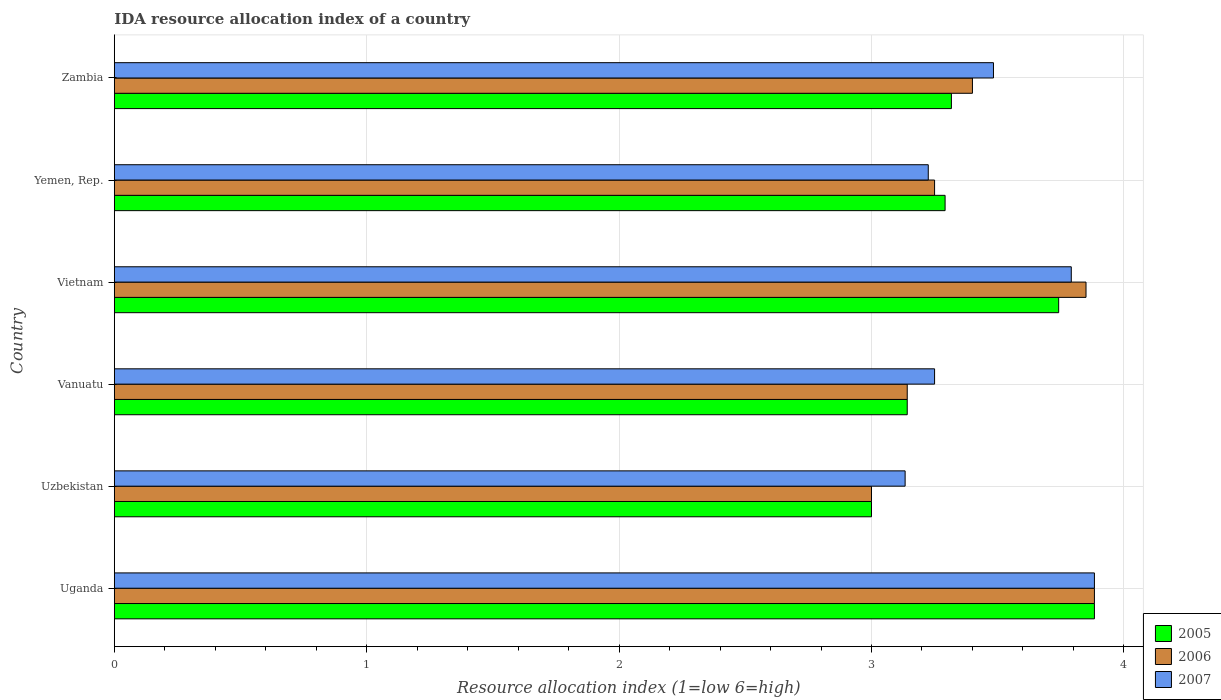How many groups of bars are there?
Your answer should be very brief. 6. How many bars are there on the 2nd tick from the bottom?
Provide a short and direct response. 3. What is the label of the 3rd group of bars from the top?
Your response must be concise. Vietnam. In how many cases, is the number of bars for a given country not equal to the number of legend labels?
Offer a very short reply. 0. What is the IDA resource allocation index in 2006 in Vanuatu?
Your response must be concise. 3.14. Across all countries, what is the maximum IDA resource allocation index in 2007?
Offer a very short reply. 3.88. Across all countries, what is the minimum IDA resource allocation index in 2006?
Provide a succinct answer. 3. In which country was the IDA resource allocation index in 2005 maximum?
Provide a short and direct response. Uganda. In which country was the IDA resource allocation index in 2007 minimum?
Ensure brevity in your answer.  Uzbekistan. What is the total IDA resource allocation index in 2006 in the graph?
Your response must be concise. 20.52. What is the difference between the IDA resource allocation index in 2007 in Uganda and that in Zambia?
Your answer should be compact. 0.4. What is the difference between the IDA resource allocation index in 2007 in Uganda and the IDA resource allocation index in 2006 in Vanuatu?
Provide a succinct answer. 0.74. What is the average IDA resource allocation index in 2005 per country?
Your answer should be very brief. 3.4. What is the difference between the IDA resource allocation index in 2007 and IDA resource allocation index in 2006 in Uzbekistan?
Provide a short and direct response. 0.13. In how many countries, is the IDA resource allocation index in 2007 greater than 3.4 ?
Ensure brevity in your answer.  3. What is the ratio of the IDA resource allocation index in 2007 in Vanuatu to that in Zambia?
Provide a short and direct response. 0.93. Is the difference between the IDA resource allocation index in 2007 in Yemen, Rep. and Zambia greater than the difference between the IDA resource allocation index in 2006 in Yemen, Rep. and Zambia?
Your response must be concise. No. What is the difference between the highest and the second highest IDA resource allocation index in 2006?
Offer a terse response. 0.03. What is the difference between the highest and the lowest IDA resource allocation index in 2007?
Your response must be concise. 0.75. In how many countries, is the IDA resource allocation index in 2006 greater than the average IDA resource allocation index in 2006 taken over all countries?
Ensure brevity in your answer.  2. Is the sum of the IDA resource allocation index in 2007 in Vanuatu and Zambia greater than the maximum IDA resource allocation index in 2006 across all countries?
Your answer should be very brief. Yes. What does the 1st bar from the top in Vietnam represents?
Your answer should be compact. 2007. What does the 1st bar from the bottom in Uzbekistan represents?
Your answer should be very brief. 2005. Are all the bars in the graph horizontal?
Offer a very short reply. Yes. What is the difference between two consecutive major ticks on the X-axis?
Make the answer very short. 1. Are the values on the major ticks of X-axis written in scientific E-notation?
Offer a very short reply. No. Does the graph contain any zero values?
Provide a short and direct response. No. Does the graph contain grids?
Your answer should be compact. Yes. Where does the legend appear in the graph?
Make the answer very short. Bottom right. How are the legend labels stacked?
Your answer should be compact. Vertical. What is the title of the graph?
Offer a terse response. IDA resource allocation index of a country. What is the label or title of the X-axis?
Offer a terse response. Resource allocation index (1=low 6=high). What is the Resource allocation index (1=low 6=high) of 2005 in Uganda?
Make the answer very short. 3.88. What is the Resource allocation index (1=low 6=high) in 2006 in Uganda?
Provide a short and direct response. 3.88. What is the Resource allocation index (1=low 6=high) in 2007 in Uganda?
Your answer should be compact. 3.88. What is the Resource allocation index (1=low 6=high) in 2006 in Uzbekistan?
Keep it short and to the point. 3. What is the Resource allocation index (1=low 6=high) in 2007 in Uzbekistan?
Provide a short and direct response. 3.13. What is the Resource allocation index (1=low 6=high) of 2005 in Vanuatu?
Your answer should be very brief. 3.14. What is the Resource allocation index (1=low 6=high) in 2006 in Vanuatu?
Your response must be concise. 3.14. What is the Resource allocation index (1=low 6=high) of 2005 in Vietnam?
Ensure brevity in your answer.  3.74. What is the Resource allocation index (1=low 6=high) in 2006 in Vietnam?
Your answer should be very brief. 3.85. What is the Resource allocation index (1=low 6=high) of 2007 in Vietnam?
Your response must be concise. 3.79. What is the Resource allocation index (1=low 6=high) in 2005 in Yemen, Rep.?
Provide a short and direct response. 3.29. What is the Resource allocation index (1=low 6=high) in 2007 in Yemen, Rep.?
Give a very brief answer. 3.23. What is the Resource allocation index (1=low 6=high) of 2005 in Zambia?
Offer a terse response. 3.32. What is the Resource allocation index (1=low 6=high) in 2006 in Zambia?
Provide a short and direct response. 3.4. What is the Resource allocation index (1=low 6=high) in 2007 in Zambia?
Your answer should be very brief. 3.48. Across all countries, what is the maximum Resource allocation index (1=low 6=high) in 2005?
Make the answer very short. 3.88. Across all countries, what is the maximum Resource allocation index (1=low 6=high) in 2006?
Provide a succinct answer. 3.88. Across all countries, what is the maximum Resource allocation index (1=low 6=high) of 2007?
Provide a succinct answer. 3.88. Across all countries, what is the minimum Resource allocation index (1=low 6=high) in 2005?
Your answer should be compact. 3. Across all countries, what is the minimum Resource allocation index (1=low 6=high) of 2007?
Provide a short and direct response. 3.13. What is the total Resource allocation index (1=low 6=high) of 2005 in the graph?
Provide a succinct answer. 20.38. What is the total Resource allocation index (1=low 6=high) of 2006 in the graph?
Offer a very short reply. 20.52. What is the total Resource allocation index (1=low 6=high) of 2007 in the graph?
Keep it short and to the point. 20.77. What is the difference between the Resource allocation index (1=low 6=high) in 2005 in Uganda and that in Uzbekistan?
Offer a terse response. 0.88. What is the difference between the Resource allocation index (1=low 6=high) of 2006 in Uganda and that in Uzbekistan?
Keep it short and to the point. 0.88. What is the difference between the Resource allocation index (1=low 6=high) in 2005 in Uganda and that in Vanuatu?
Ensure brevity in your answer.  0.74. What is the difference between the Resource allocation index (1=low 6=high) of 2006 in Uganda and that in Vanuatu?
Your answer should be compact. 0.74. What is the difference between the Resource allocation index (1=low 6=high) of 2007 in Uganda and that in Vanuatu?
Your response must be concise. 0.63. What is the difference between the Resource allocation index (1=low 6=high) in 2005 in Uganda and that in Vietnam?
Ensure brevity in your answer.  0.14. What is the difference between the Resource allocation index (1=low 6=high) in 2006 in Uganda and that in Vietnam?
Your answer should be very brief. 0.03. What is the difference between the Resource allocation index (1=low 6=high) of 2007 in Uganda and that in Vietnam?
Ensure brevity in your answer.  0.09. What is the difference between the Resource allocation index (1=low 6=high) of 2005 in Uganda and that in Yemen, Rep.?
Offer a terse response. 0.59. What is the difference between the Resource allocation index (1=low 6=high) of 2006 in Uganda and that in Yemen, Rep.?
Provide a short and direct response. 0.63. What is the difference between the Resource allocation index (1=low 6=high) of 2007 in Uganda and that in Yemen, Rep.?
Your response must be concise. 0.66. What is the difference between the Resource allocation index (1=low 6=high) of 2005 in Uganda and that in Zambia?
Offer a very short reply. 0.57. What is the difference between the Resource allocation index (1=low 6=high) of 2006 in Uganda and that in Zambia?
Your answer should be very brief. 0.48. What is the difference between the Resource allocation index (1=low 6=high) in 2005 in Uzbekistan and that in Vanuatu?
Your response must be concise. -0.14. What is the difference between the Resource allocation index (1=low 6=high) of 2006 in Uzbekistan and that in Vanuatu?
Make the answer very short. -0.14. What is the difference between the Resource allocation index (1=low 6=high) of 2007 in Uzbekistan and that in Vanuatu?
Give a very brief answer. -0.12. What is the difference between the Resource allocation index (1=low 6=high) in 2005 in Uzbekistan and that in Vietnam?
Provide a succinct answer. -0.74. What is the difference between the Resource allocation index (1=low 6=high) in 2006 in Uzbekistan and that in Vietnam?
Your answer should be very brief. -0.85. What is the difference between the Resource allocation index (1=low 6=high) of 2007 in Uzbekistan and that in Vietnam?
Provide a short and direct response. -0.66. What is the difference between the Resource allocation index (1=low 6=high) in 2005 in Uzbekistan and that in Yemen, Rep.?
Offer a terse response. -0.29. What is the difference between the Resource allocation index (1=low 6=high) in 2006 in Uzbekistan and that in Yemen, Rep.?
Ensure brevity in your answer.  -0.25. What is the difference between the Resource allocation index (1=low 6=high) in 2007 in Uzbekistan and that in Yemen, Rep.?
Your answer should be very brief. -0.09. What is the difference between the Resource allocation index (1=low 6=high) of 2005 in Uzbekistan and that in Zambia?
Keep it short and to the point. -0.32. What is the difference between the Resource allocation index (1=low 6=high) in 2006 in Uzbekistan and that in Zambia?
Provide a succinct answer. -0.4. What is the difference between the Resource allocation index (1=low 6=high) in 2007 in Uzbekistan and that in Zambia?
Keep it short and to the point. -0.35. What is the difference between the Resource allocation index (1=low 6=high) in 2006 in Vanuatu and that in Vietnam?
Provide a succinct answer. -0.71. What is the difference between the Resource allocation index (1=low 6=high) in 2007 in Vanuatu and that in Vietnam?
Give a very brief answer. -0.54. What is the difference between the Resource allocation index (1=low 6=high) in 2005 in Vanuatu and that in Yemen, Rep.?
Provide a succinct answer. -0.15. What is the difference between the Resource allocation index (1=low 6=high) of 2006 in Vanuatu and that in Yemen, Rep.?
Your response must be concise. -0.11. What is the difference between the Resource allocation index (1=low 6=high) of 2007 in Vanuatu and that in Yemen, Rep.?
Make the answer very short. 0.03. What is the difference between the Resource allocation index (1=low 6=high) in 2005 in Vanuatu and that in Zambia?
Your answer should be compact. -0.17. What is the difference between the Resource allocation index (1=low 6=high) in 2006 in Vanuatu and that in Zambia?
Your answer should be compact. -0.26. What is the difference between the Resource allocation index (1=low 6=high) of 2007 in Vanuatu and that in Zambia?
Keep it short and to the point. -0.23. What is the difference between the Resource allocation index (1=low 6=high) of 2005 in Vietnam and that in Yemen, Rep.?
Offer a very short reply. 0.45. What is the difference between the Resource allocation index (1=low 6=high) of 2006 in Vietnam and that in Yemen, Rep.?
Offer a very short reply. 0.6. What is the difference between the Resource allocation index (1=low 6=high) of 2007 in Vietnam and that in Yemen, Rep.?
Provide a succinct answer. 0.57. What is the difference between the Resource allocation index (1=low 6=high) in 2005 in Vietnam and that in Zambia?
Offer a very short reply. 0.42. What is the difference between the Resource allocation index (1=low 6=high) in 2006 in Vietnam and that in Zambia?
Provide a succinct answer. 0.45. What is the difference between the Resource allocation index (1=low 6=high) in 2007 in Vietnam and that in Zambia?
Your answer should be compact. 0.31. What is the difference between the Resource allocation index (1=low 6=high) in 2005 in Yemen, Rep. and that in Zambia?
Provide a short and direct response. -0.03. What is the difference between the Resource allocation index (1=low 6=high) in 2007 in Yemen, Rep. and that in Zambia?
Ensure brevity in your answer.  -0.26. What is the difference between the Resource allocation index (1=low 6=high) of 2005 in Uganda and the Resource allocation index (1=low 6=high) of 2006 in Uzbekistan?
Provide a succinct answer. 0.88. What is the difference between the Resource allocation index (1=low 6=high) of 2005 in Uganda and the Resource allocation index (1=low 6=high) of 2006 in Vanuatu?
Give a very brief answer. 0.74. What is the difference between the Resource allocation index (1=low 6=high) in 2005 in Uganda and the Resource allocation index (1=low 6=high) in 2007 in Vanuatu?
Your answer should be compact. 0.63. What is the difference between the Resource allocation index (1=low 6=high) of 2006 in Uganda and the Resource allocation index (1=low 6=high) of 2007 in Vanuatu?
Make the answer very short. 0.63. What is the difference between the Resource allocation index (1=low 6=high) in 2005 in Uganda and the Resource allocation index (1=low 6=high) in 2006 in Vietnam?
Your answer should be very brief. 0.03. What is the difference between the Resource allocation index (1=low 6=high) in 2005 in Uganda and the Resource allocation index (1=low 6=high) in 2007 in Vietnam?
Provide a succinct answer. 0.09. What is the difference between the Resource allocation index (1=low 6=high) of 2006 in Uganda and the Resource allocation index (1=low 6=high) of 2007 in Vietnam?
Make the answer very short. 0.09. What is the difference between the Resource allocation index (1=low 6=high) of 2005 in Uganda and the Resource allocation index (1=low 6=high) of 2006 in Yemen, Rep.?
Your response must be concise. 0.63. What is the difference between the Resource allocation index (1=low 6=high) of 2005 in Uganda and the Resource allocation index (1=low 6=high) of 2007 in Yemen, Rep.?
Ensure brevity in your answer.  0.66. What is the difference between the Resource allocation index (1=low 6=high) in 2006 in Uganda and the Resource allocation index (1=low 6=high) in 2007 in Yemen, Rep.?
Provide a short and direct response. 0.66. What is the difference between the Resource allocation index (1=low 6=high) of 2005 in Uganda and the Resource allocation index (1=low 6=high) of 2006 in Zambia?
Your answer should be very brief. 0.48. What is the difference between the Resource allocation index (1=low 6=high) of 2005 in Uzbekistan and the Resource allocation index (1=low 6=high) of 2006 in Vanuatu?
Give a very brief answer. -0.14. What is the difference between the Resource allocation index (1=low 6=high) in 2005 in Uzbekistan and the Resource allocation index (1=low 6=high) in 2006 in Vietnam?
Your answer should be compact. -0.85. What is the difference between the Resource allocation index (1=low 6=high) in 2005 in Uzbekistan and the Resource allocation index (1=low 6=high) in 2007 in Vietnam?
Give a very brief answer. -0.79. What is the difference between the Resource allocation index (1=low 6=high) of 2006 in Uzbekistan and the Resource allocation index (1=low 6=high) of 2007 in Vietnam?
Your answer should be very brief. -0.79. What is the difference between the Resource allocation index (1=low 6=high) of 2005 in Uzbekistan and the Resource allocation index (1=low 6=high) of 2007 in Yemen, Rep.?
Your answer should be very brief. -0.23. What is the difference between the Resource allocation index (1=low 6=high) of 2006 in Uzbekistan and the Resource allocation index (1=low 6=high) of 2007 in Yemen, Rep.?
Provide a succinct answer. -0.23. What is the difference between the Resource allocation index (1=low 6=high) of 2005 in Uzbekistan and the Resource allocation index (1=low 6=high) of 2006 in Zambia?
Provide a short and direct response. -0.4. What is the difference between the Resource allocation index (1=low 6=high) in 2005 in Uzbekistan and the Resource allocation index (1=low 6=high) in 2007 in Zambia?
Keep it short and to the point. -0.48. What is the difference between the Resource allocation index (1=low 6=high) of 2006 in Uzbekistan and the Resource allocation index (1=low 6=high) of 2007 in Zambia?
Give a very brief answer. -0.48. What is the difference between the Resource allocation index (1=low 6=high) in 2005 in Vanuatu and the Resource allocation index (1=low 6=high) in 2006 in Vietnam?
Provide a short and direct response. -0.71. What is the difference between the Resource allocation index (1=low 6=high) in 2005 in Vanuatu and the Resource allocation index (1=low 6=high) in 2007 in Vietnam?
Your response must be concise. -0.65. What is the difference between the Resource allocation index (1=low 6=high) of 2006 in Vanuatu and the Resource allocation index (1=low 6=high) of 2007 in Vietnam?
Give a very brief answer. -0.65. What is the difference between the Resource allocation index (1=low 6=high) in 2005 in Vanuatu and the Resource allocation index (1=low 6=high) in 2006 in Yemen, Rep.?
Your response must be concise. -0.11. What is the difference between the Resource allocation index (1=low 6=high) of 2005 in Vanuatu and the Resource allocation index (1=low 6=high) of 2007 in Yemen, Rep.?
Your response must be concise. -0.08. What is the difference between the Resource allocation index (1=low 6=high) in 2006 in Vanuatu and the Resource allocation index (1=low 6=high) in 2007 in Yemen, Rep.?
Offer a very short reply. -0.08. What is the difference between the Resource allocation index (1=low 6=high) of 2005 in Vanuatu and the Resource allocation index (1=low 6=high) of 2006 in Zambia?
Your answer should be compact. -0.26. What is the difference between the Resource allocation index (1=low 6=high) of 2005 in Vanuatu and the Resource allocation index (1=low 6=high) of 2007 in Zambia?
Provide a short and direct response. -0.34. What is the difference between the Resource allocation index (1=low 6=high) in 2006 in Vanuatu and the Resource allocation index (1=low 6=high) in 2007 in Zambia?
Ensure brevity in your answer.  -0.34. What is the difference between the Resource allocation index (1=low 6=high) in 2005 in Vietnam and the Resource allocation index (1=low 6=high) in 2006 in Yemen, Rep.?
Your response must be concise. 0.49. What is the difference between the Resource allocation index (1=low 6=high) in 2005 in Vietnam and the Resource allocation index (1=low 6=high) in 2007 in Yemen, Rep.?
Ensure brevity in your answer.  0.52. What is the difference between the Resource allocation index (1=low 6=high) of 2006 in Vietnam and the Resource allocation index (1=low 6=high) of 2007 in Yemen, Rep.?
Your answer should be compact. 0.62. What is the difference between the Resource allocation index (1=low 6=high) of 2005 in Vietnam and the Resource allocation index (1=low 6=high) of 2006 in Zambia?
Give a very brief answer. 0.34. What is the difference between the Resource allocation index (1=low 6=high) in 2005 in Vietnam and the Resource allocation index (1=low 6=high) in 2007 in Zambia?
Give a very brief answer. 0.26. What is the difference between the Resource allocation index (1=low 6=high) of 2006 in Vietnam and the Resource allocation index (1=low 6=high) of 2007 in Zambia?
Provide a short and direct response. 0.37. What is the difference between the Resource allocation index (1=low 6=high) of 2005 in Yemen, Rep. and the Resource allocation index (1=low 6=high) of 2006 in Zambia?
Offer a terse response. -0.11. What is the difference between the Resource allocation index (1=low 6=high) of 2005 in Yemen, Rep. and the Resource allocation index (1=low 6=high) of 2007 in Zambia?
Provide a short and direct response. -0.19. What is the difference between the Resource allocation index (1=low 6=high) in 2006 in Yemen, Rep. and the Resource allocation index (1=low 6=high) in 2007 in Zambia?
Give a very brief answer. -0.23. What is the average Resource allocation index (1=low 6=high) of 2005 per country?
Provide a short and direct response. 3.4. What is the average Resource allocation index (1=low 6=high) of 2006 per country?
Provide a succinct answer. 3.42. What is the average Resource allocation index (1=low 6=high) of 2007 per country?
Keep it short and to the point. 3.46. What is the difference between the Resource allocation index (1=low 6=high) of 2006 and Resource allocation index (1=low 6=high) of 2007 in Uganda?
Keep it short and to the point. 0. What is the difference between the Resource allocation index (1=low 6=high) of 2005 and Resource allocation index (1=low 6=high) of 2007 in Uzbekistan?
Your answer should be compact. -0.13. What is the difference between the Resource allocation index (1=low 6=high) in 2006 and Resource allocation index (1=low 6=high) in 2007 in Uzbekistan?
Give a very brief answer. -0.13. What is the difference between the Resource allocation index (1=low 6=high) in 2005 and Resource allocation index (1=low 6=high) in 2007 in Vanuatu?
Make the answer very short. -0.11. What is the difference between the Resource allocation index (1=low 6=high) in 2006 and Resource allocation index (1=low 6=high) in 2007 in Vanuatu?
Give a very brief answer. -0.11. What is the difference between the Resource allocation index (1=low 6=high) in 2005 and Resource allocation index (1=low 6=high) in 2006 in Vietnam?
Keep it short and to the point. -0.11. What is the difference between the Resource allocation index (1=low 6=high) of 2005 and Resource allocation index (1=low 6=high) of 2007 in Vietnam?
Provide a short and direct response. -0.05. What is the difference between the Resource allocation index (1=low 6=high) in 2006 and Resource allocation index (1=low 6=high) in 2007 in Vietnam?
Offer a terse response. 0.06. What is the difference between the Resource allocation index (1=low 6=high) of 2005 and Resource allocation index (1=low 6=high) of 2006 in Yemen, Rep.?
Offer a very short reply. 0.04. What is the difference between the Resource allocation index (1=low 6=high) of 2005 and Resource allocation index (1=low 6=high) of 2007 in Yemen, Rep.?
Your answer should be compact. 0.07. What is the difference between the Resource allocation index (1=low 6=high) in 2006 and Resource allocation index (1=low 6=high) in 2007 in Yemen, Rep.?
Provide a succinct answer. 0.03. What is the difference between the Resource allocation index (1=low 6=high) in 2005 and Resource allocation index (1=low 6=high) in 2006 in Zambia?
Your response must be concise. -0.08. What is the difference between the Resource allocation index (1=low 6=high) of 2006 and Resource allocation index (1=low 6=high) of 2007 in Zambia?
Offer a terse response. -0.08. What is the ratio of the Resource allocation index (1=low 6=high) of 2005 in Uganda to that in Uzbekistan?
Provide a short and direct response. 1.29. What is the ratio of the Resource allocation index (1=low 6=high) in 2006 in Uganda to that in Uzbekistan?
Provide a short and direct response. 1.29. What is the ratio of the Resource allocation index (1=low 6=high) in 2007 in Uganda to that in Uzbekistan?
Offer a very short reply. 1.24. What is the ratio of the Resource allocation index (1=low 6=high) in 2005 in Uganda to that in Vanuatu?
Provide a succinct answer. 1.24. What is the ratio of the Resource allocation index (1=low 6=high) in 2006 in Uganda to that in Vanuatu?
Give a very brief answer. 1.24. What is the ratio of the Resource allocation index (1=low 6=high) of 2007 in Uganda to that in Vanuatu?
Make the answer very short. 1.19. What is the ratio of the Resource allocation index (1=low 6=high) of 2005 in Uganda to that in Vietnam?
Ensure brevity in your answer.  1.04. What is the ratio of the Resource allocation index (1=low 6=high) of 2006 in Uganda to that in Vietnam?
Keep it short and to the point. 1.01. What is the ratio of the Resource allocation index (1=low 6=high) in 2007 in Uganda to that in Vietnam?
Make the answer very short. 1.02. What is the ratio of the Resource allocation index (1=low 6=high) in 2005 in Uganda to that in Yemen, Rep.?
Keep it short and to the point. 1.18. What is the ratio of the Resource allocation index (1=low 6=high) in 2006 in Uganda to that in Yemen, Rep.?
Give a very brief answer. 1.19. What is the ratio of the Resource allocation index (1=low 6=high) in 2007 in Uganda to that in Yemen, Rep.?
Offer a terse response. 1.2. What is the ratio of the Resource allocation index (1=low 6=high) in 2005 in Uganda to that in Zambia?
Make the answer very short. 1.17. What is the ratio of the Resource allocation index (1=low 6=high) in 2006 in Uganda to that in Zambia?
Give a very brief answer. 1.14. What is the ratio of the Resource allocation index (1=low 6=high) in 2007 in Uganda to that in Zambia?
Your answer should be compact. 1.11. What is the ratio of the Resource allocation index (1=low 6=high) in 2005 in Uzbekistan to that in Vanuatu?
Ensure brevity in your answer.  0.95. What is the ratio of the Resource allocation index (1=low 6=high) of 2006 in Uzbekistan to that in Vanuatu?
Offer a very short reply. 0.95. What is the ratio of the Resource allocation index (1=low 6=high) of 2007 in Uzbekistan to that in Vanuatu?
Give a very brief answer. 0.96. What is the ratio of the Resource allocation index (1=low 6=high) of 2005 in Uzbekistan to that in Vietnam?
Keep it short and to the point. 0.8. What is the ratio of the Resource allocation index (1=low 6=high) of 2006 in Uzbekistan to that in Vietnam?
Your response must be concise. 0.78. What is the ratio of the Resource allocation index (1=low 6=high) of 2007 in Uzbekistan to that in Vietnam?
Your response must be concise. 0.83. What is the ratio of the Resource allocation index (1=low 6=high) in 2005 in Uzbekistan to that in Yemen, Rep.?
Offer a very short reply. 0.91. What is the ratio of the Resource allocation index (1=low 6=high) of 2007 in Uzbekistan to that in Yemen, Rep.?
Provide a succinct answer. 0.97. What is the ratio of the Resource allocation index (1=low 6=high) in 2005 in Uzbekistan to that in Zambia?
Keep it short and to the point. 0.9. What is the ratio of the Resource allocation index (1=low 6=high) of 2006 in Uzbekistan to that in Zambia?
Provide a short and direct response. 0.88. What is the ratio of the Resource allocation index (1=low 6=high) of 2007 in Uzbekistan to that in Zambia?
Provide a short and direct response. 0.9. What is the ratio of the Resource allocation index (1=low 6=high) of 2005 in Vanuatu to that in Vietnam?
Make the answer very short. 0.84. What is the ratio of the Resource allocation index (1=low 6=high) in 2006 in Vanuatu to that in Vietnam?
Keep it short and to the point. 0.82. What is the ratio of the Resource allocation index (1=low 6=high) of 2005 in Vanuatu to that in Yemen, Rep.?
Make the answer very short. 0.95. What is the ratio of the Resource allocation index (1=low 6=high) in 2006 in Vanuatu to that in Yemen, Rep.?
Keep it short and to the point. 0.97. What is the ratio of the Resource allocation index (1=low 6=high) of 2005 in Vanuatu to that in Zambia?
Your answer should be very brief. 0.95. What is the ratio of the Resource allocation index (1=low 6=high) in 2006 in Vanuatu to that in Zambia?
Keep it short and to the point. 0.92. What is the ratio of the Resource allocation index (1=low 6=high) of 2007 in Vanuatu to that in Zambia?
Your answer should be very brief. 0.93. What is the ratio of the Resource allocation index (1=low 6=high) in 2005 in Vietnam to that in Yemen, Rep.?
Keep it short and to the point. 1.14. What is the ratio of the Resource allocation index (1=low 6=high) in 2006 in Vietnam to that in Yemen, Rep.?
Offer a terse response. 1.18. What is the ratio of the Resource allocation index (1=low 6=high) of 2007 in Vietnam to that in Yemen, Rep.?
Make the answer very short. 1.18. What is the ratio of the Resource allocation index (1=low 6=high) of 2005 in Vietnam to that in Zambia?
Your response must be concise. 1.13. What is the ratio of the Resource allocation index (1=low 6=high) in 2006 in Vietnam to that in Zambia?
Ensure brevity in your answer.  1.13. What is the ratio of the Resource allocation index (1=low 6=high) of 2007 in Vietnam to that in Zambia?
Give a very brief answer. 1.09. What is the ratio of the Resource allocation index (1=low 6=high) in 2006 in Yemen, Rep. to that in Zambia?
Offer a very short reply. 0.96. What is the ratio of the Resource allocation index (1=low 6=high) in 2007 in Yemen, Rep. to that in Zambia?
Provide a succinct answer. 0.93. What is the difference between the highest and the second highest Resource allocation index (1=low 6=high) in 2005?
Your response must be concise. 0.14. What is the difference between the highest and the second highest Resource allocation index (1=low 6=high) of 2006?
Make the answer very short. 0.03. What is the difference between the highest and the second highest Resource allocation index (1=low 6=high) of 2007?
Keep it short and to the point. 0.09. What is the difference between the highest and the lowest Resource allocation index (1=low 6=high) in 2005?
Make the answer very short. 0.88. What is the difference between the highest and the lowest Resource allocation index (1=low 6=high) in 2006?
Your response must be concise. 0.88. What is the difference between the highest and the lowest Resource allocation index (1=low 6=high) in 2007?
Provide a succinct answer. 0.75. 